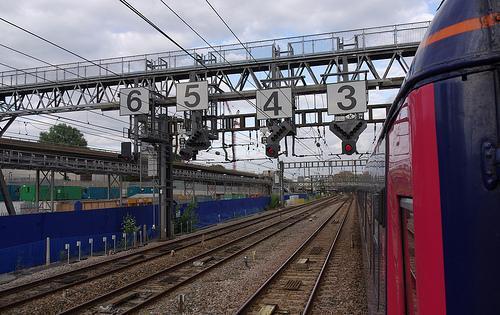How many numbers are there?
Give a very brief answer. 4. 